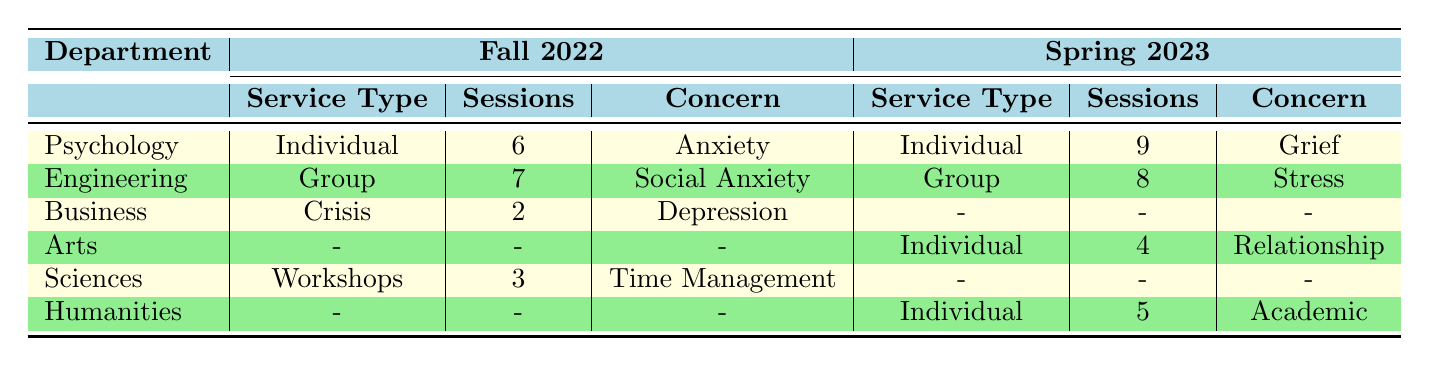What is the total number of counseling sessions attended by students in the Psychology department in Fall 2022? There is one entry for the Psychology department in Fall 2022, which shows that 6 sessions were attended in Individual Counseling. Therefore, the total number of sessions for that semester in that department is 6.
Answer: 6 Which department had the highest number of counseling sessions attended in Spring 2023? The entries for Spring 2023 are Engineering (8 sessions), Arts (4 sessions), and Humanities (5 sessions). The highest number of sessions is in the Engineering department with 8 sessions attended in Group Therapy.
Answer: Engineering Did the Business department utilize counseling services in Spring 2023? The table shows that in Spring 2023, the Business department does not have any entries for counseling services as marked by a dash (-). Therefore, the answer is no.
Answer: No What is the average number of sessions attended for students receiving Individual Counseling across both semesters? In Fall 2022, 6 sessions in Psychology and 0 in Business (no Individual Counseling). In Spring 2023, there were 9 in Psychology and 4 in Arts, totaling 19 sessions across 4 students. The average is calculated as 19/4 = 4.75.
Answer: 4.75 Which counseling service type had the most sessions attended in Fall 2022? In Fall 2022, we have Individual Counseling with 6 sessions in Psychology, Group Therapy with 7 sessions in Engineering, and Workshops with 3 sessions in Sciences. The maximum is 7 sessions in Group Therapy from Engineering.
Answer: Group Therapy How many different primary concerns were addressed by the students using counseling services in Spring 2023? The primary concerns from Spring 2023 are Grief (Psychology), Stress (Engineering), Relationship Issues (Arts), and Academic Pressure (Humanities). There are 4 different concerns listed.
Answer: 4 In which semester did the Engineering department have more counseling sessions attended? In Fall 2022, Engineering had 7 sessions in Group Therapy. In Spring 2023, they had 8 sessions. Comparing the numbers, Spring 2023 had more, with 8 sessions compared to 7 sessions in Fall 2022.
Answer: Spring 2023 Is there any business student who attended a crisis intervention session? The data shows that in Fall 2022, a Business student attended 2 sessions of Crisis Intervention. Therefore, there is at least one business student who utilized this service.
Answer: Yes Which semester had more total counseling sessions attended across all departments? Total for Fall 2022: 6 (Psychology) + 7 (Engineering) + 2 (Business) + 3 (Sciences) = 18 sessions. Total for Spring 2023: 9 (Psychology) + 8 (Engineering) + 4 (Arts) + 5 (Humanities) + 1 (Arts) = 27 sessions. Since 27 is greater than 18, Spring 2023 had more sessions.
Answer: Spring 2023 